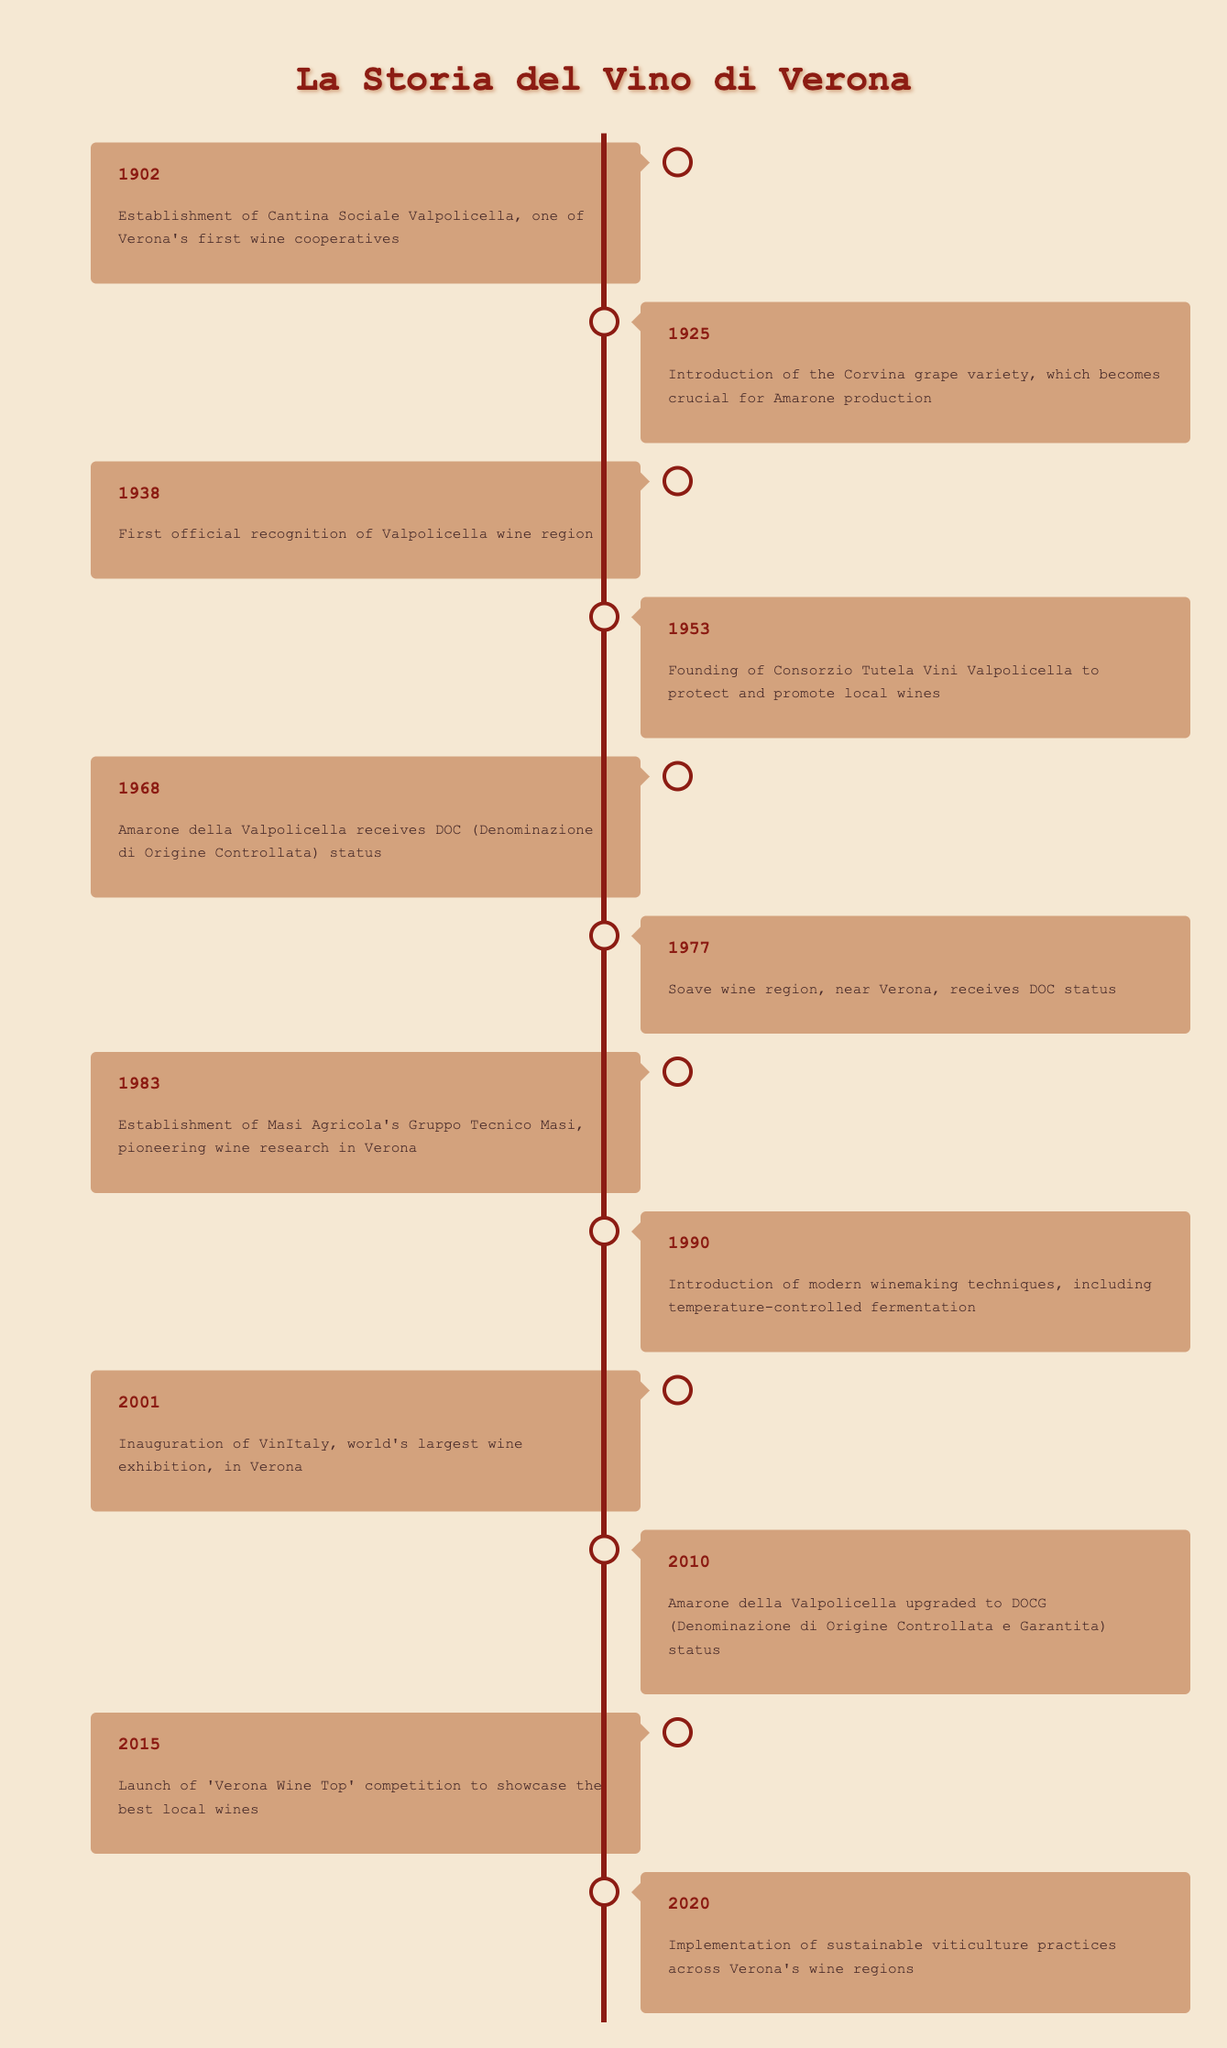What year was the Cantina Sociale Valpolicella established? The table indicates that Cantina Sociale Valpolicella was established in 1902. The specific event associated with this year confirms the information.
Answer: 1902 Which wine region received DOC status in 1977? In the year 1977, the table shows that the Soave wine region received DOC status. The entry explicitly states this information.
Answer: Soave How many years passed between the establishment of the Consorzio Tutela Vini Valpolicella and the DOC status of Amarone? The Consorzio Tutela Vini Valpolicella was founded in 1953, and Amarone received its DOC status in 1968. To find the difference, subtract 1953 from 1968, which is 15 years.
Answer: 15 years Is it true that Verona saw the launch of the daily 'Verona Wine Top' competition in 2015? The table clearly states that the 'Verona Wine Top' competition launched in 2015, which confirms the statement is true.
Answer: True Which milestone came first: the introduction of the Corvina grape variety or the inauguration of VinItaly? According to the timeline, the Corvina grape variety was introduced in 1925 and VinItaly was inaugurated in 2001. Thus, the introduction of the grape variety came first as 1925 is earlier than 2001.
Answer: Introduction of the Corvina grape variety How many significant milestones happened between 2000 and 2020? The table lists three events from 2001 to 2020: the inauguration of VinItaly in 2001, Amarone being upgraded to DOCG status in 2010, and the implementation of sustainable viticulture practices in 2020. This accounts for three significant milestones.
Answer: 3 milestones What is the difference in years between the first recognition of the Valpolicella wine region and the launch of the sustainable viticulture practices? The first recognition of the Valpolicella wine region occurred in 1938, and sustainable viticulture practices were implemented in 2020. To calculate the difference, subtract 1938 from 2020, which equals 82 years.
Answer: 82 years Did Verona's wine industry see the application of modern winemaking techniques before 2000? The table indicates that modern winemaking techniques were introduced in 1990, which confirms that this occurred before the year 2000. Thus, the statement is true.
Answer: True 